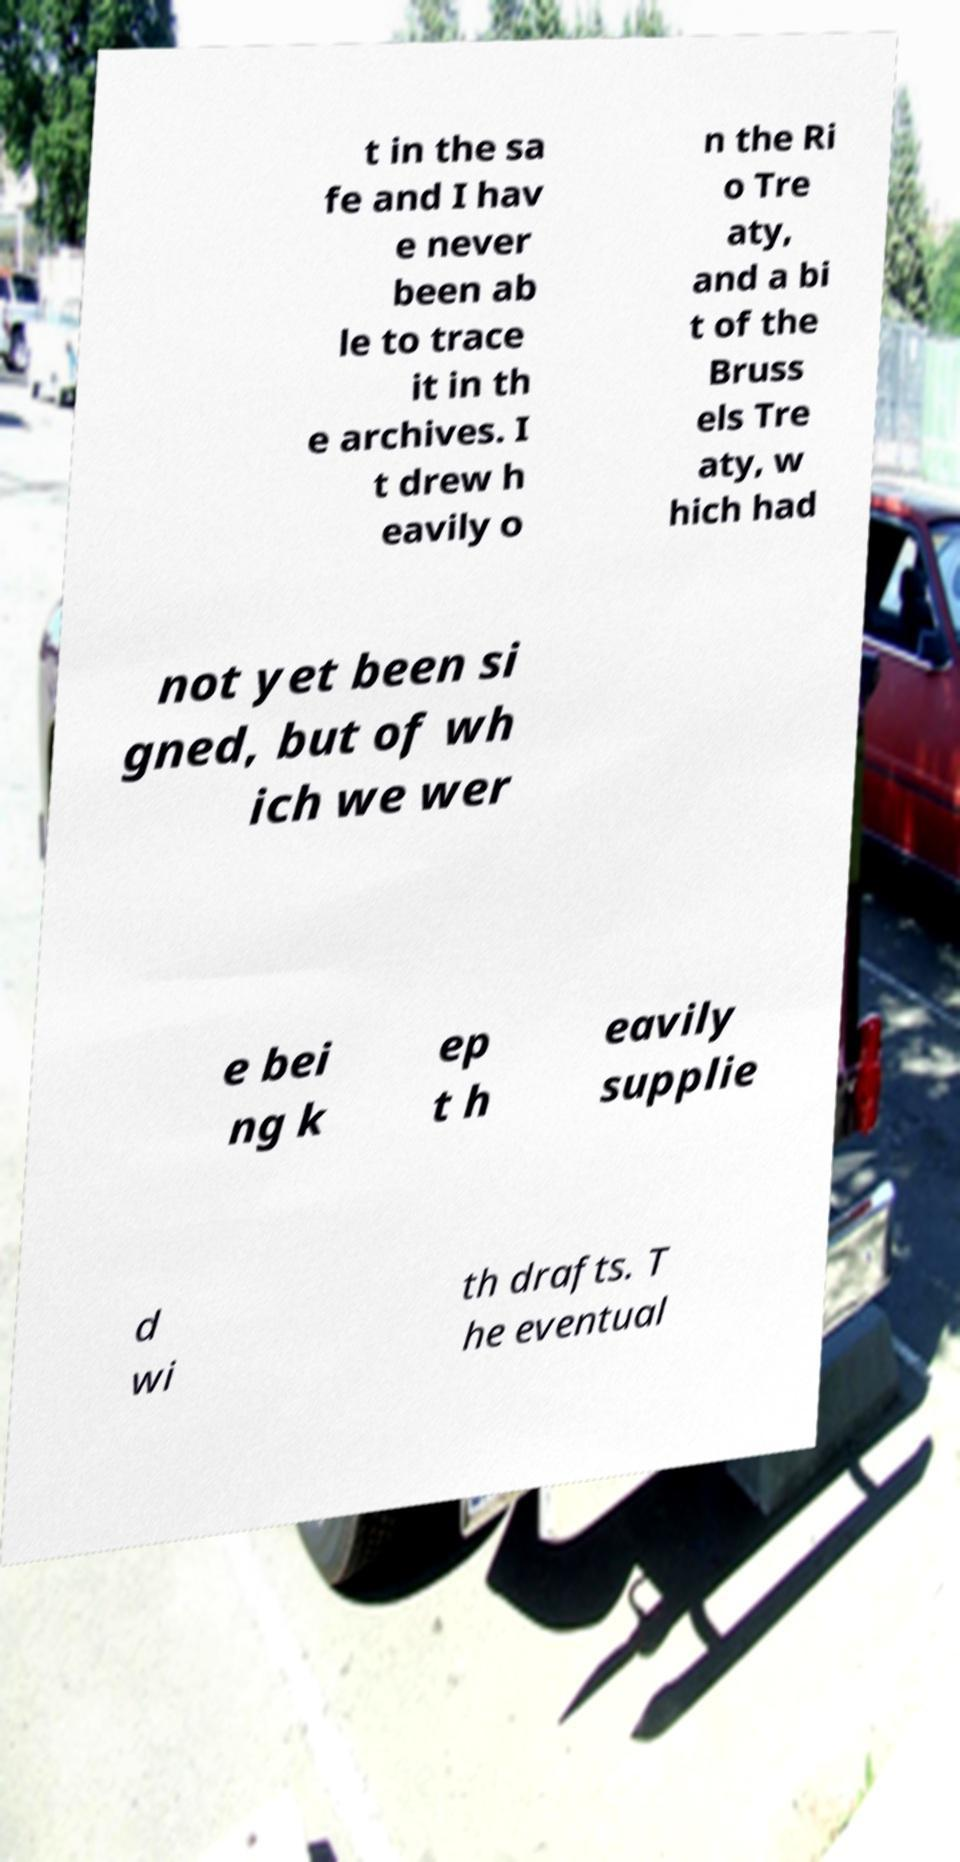Please read and relay the text visible in this image. What does it say? t in the sa fe and I hav e never been ab le to trace it in th e archives. I t drew h eavily o n the Ri o Tre aty, and a bi t of the Bruss els Tre aty, w hich had not yet been si gned, but of wh ich we wer e bei ng k ep t h eavily supplie d wi th drafts. T he eventual 